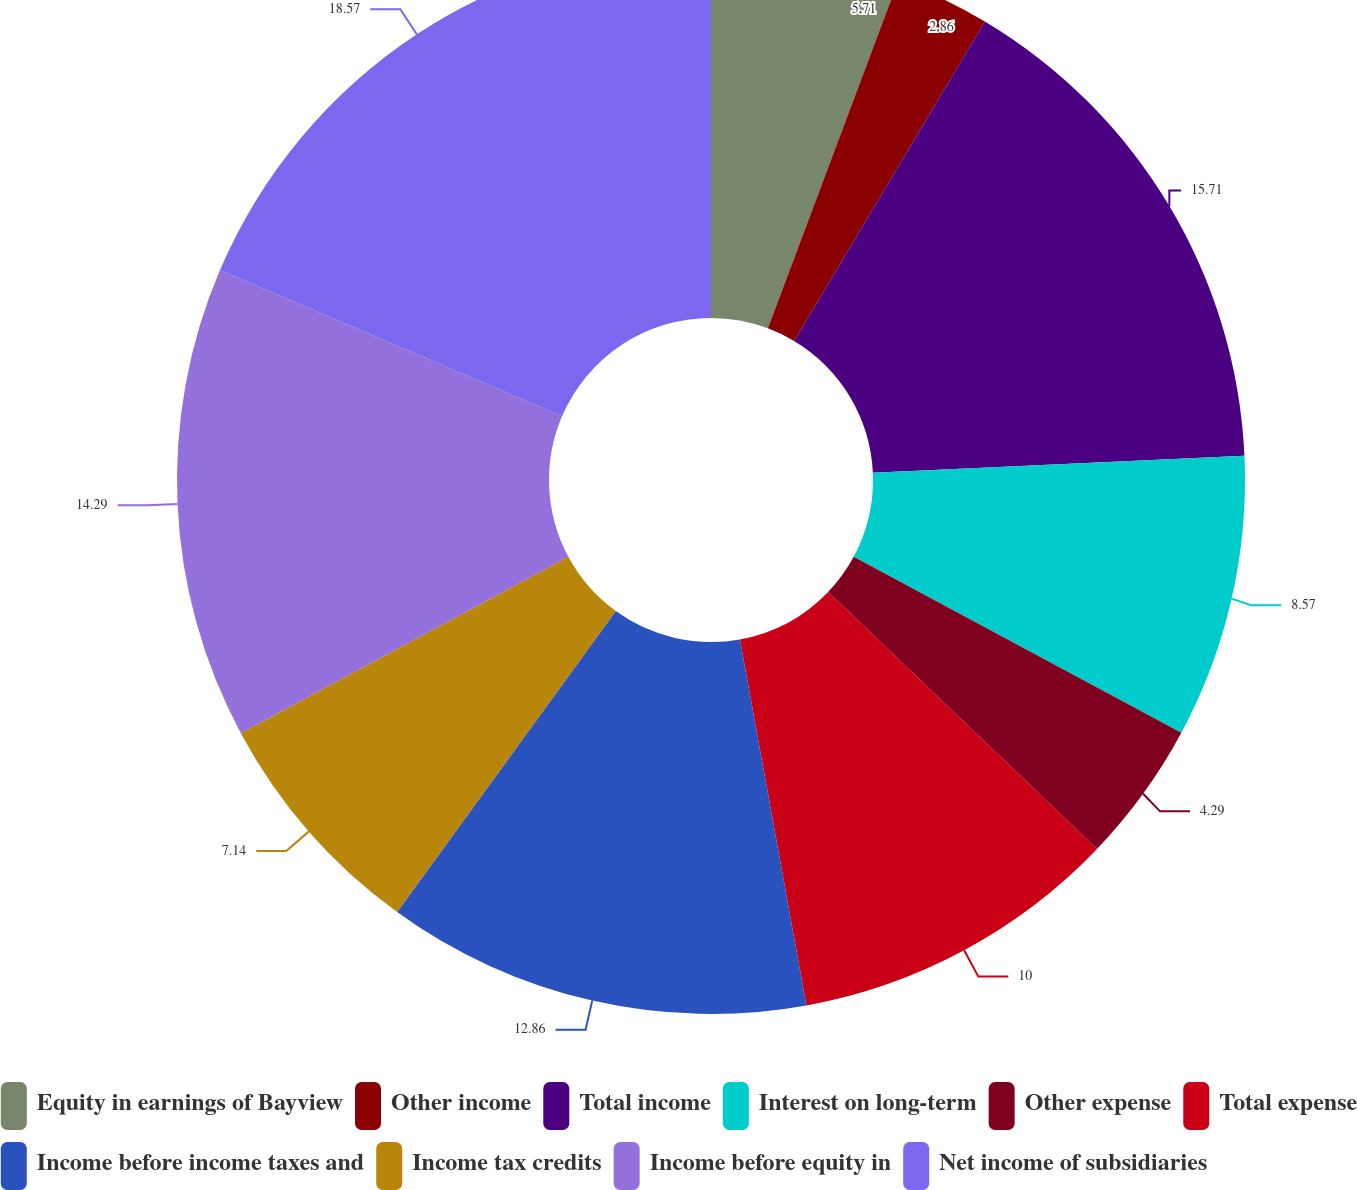<chart> <loc_0><loc_0><loc_500><loc_500><pie_chart><fcel>Equity in earnings of Bayview<fcel>Other income<fcel>Total income<fcel>Interest on long-term<fcel>Other expense<fcel>Total expense<fcel>Income before income taxes and<fcel>Income tax credits<fcel>Income before equity in<fcel>Net income of subsidiaries<nl><fcel>5.71%<fcel>2.86%<fcel>15.71%<fcel>8.57%<fcel>4.29%<fcel>10.0%<fcel>12.86%<fcel>7.14%<fcel>14.29%<fcel>18.57%<nl></chart> 